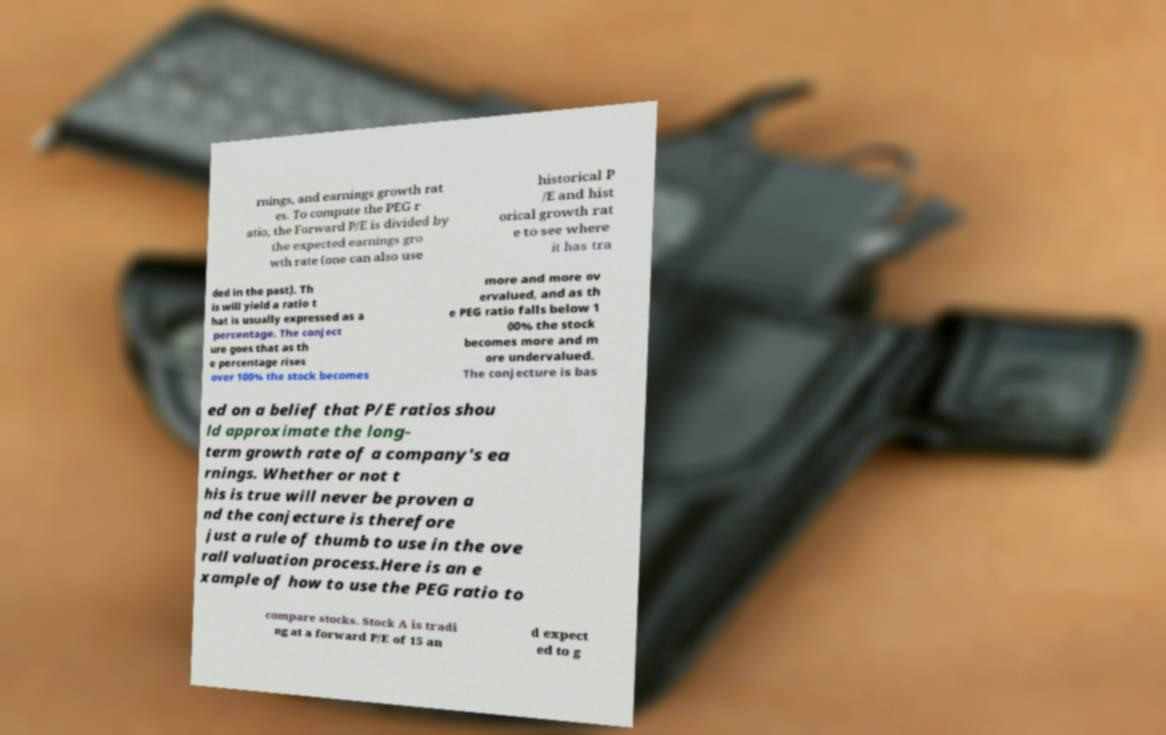What messages or text are displayed in this image? I need them in a readable, typed format. rnings, and earnings growth rat es. To compute the PEG r atio, the Forward P/E is divided by the expected earnings gro wth rate (one can also use historical P /E and hist orical growth rat e to see where it has tra ded in the past). Th is will yield a ratio t hat is usually expressed as a percentage. The conject ure goes that as th e percentage rises over 100% the stock becomes more and more ov ervalued, and as th e PEG ratio falls below 1 00% the stock becomes more and m ore undervalued. The conjecture is bas ed on a belief that P/E ratios shou ld approximate the long- term growth rate of a company's ea rnings. Whether or not t his is true will never be proven a nd the conjecture is therefore just a rule of thumb to use in the ove rall valuation process.Here is an e xample of how to use the PEG ratio to compare stocks. Stock A is tradi ng at a forward P/E of 15 an d expect ed to g 